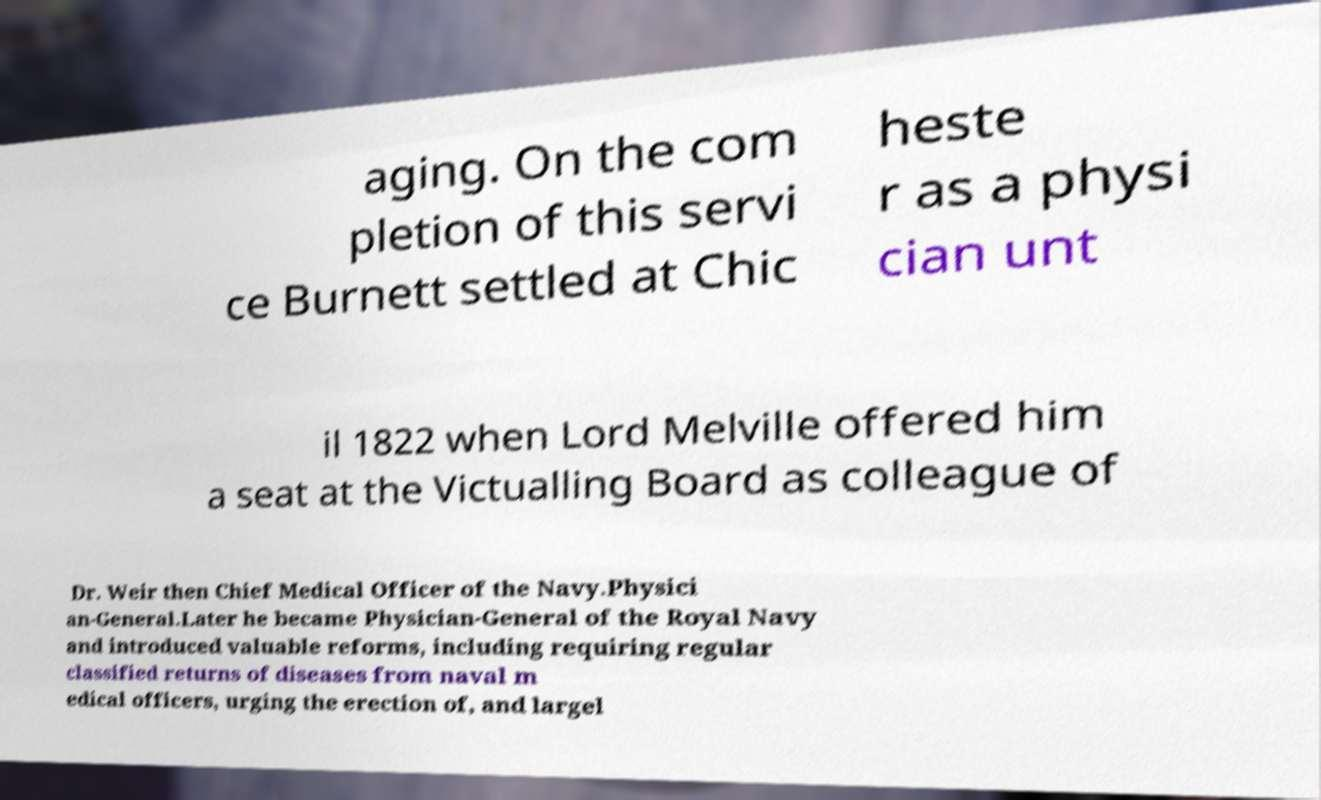Can you accurately transcribe the text from the provided image for me? aging. On the com pletion of this servi ce Burnett settled at Chic heste r as a physi cian unt il 1822 when Lord Melville offered him a seat at the Victualling Board as colleague of Dr. Weir then Chief Medical Officer of the Navy.Physici an-General.Later he became Physician-General of the Royal Navy and introduced valuable reforms, including requiring regular classified returns of diseases from naval m edical officers, urging the erection of, and largel 